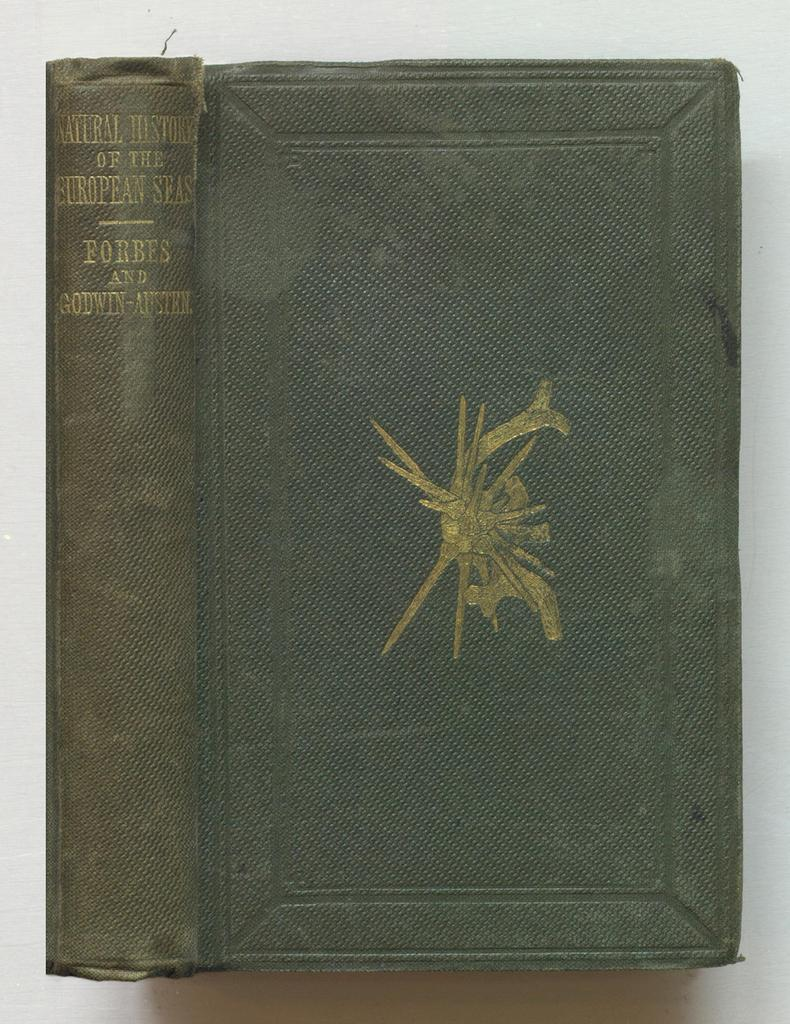<image>
Relay a brief, clear account of the picture shown. A dusty old green book on the European Seas, has a gold logo in the middle of the cover. 